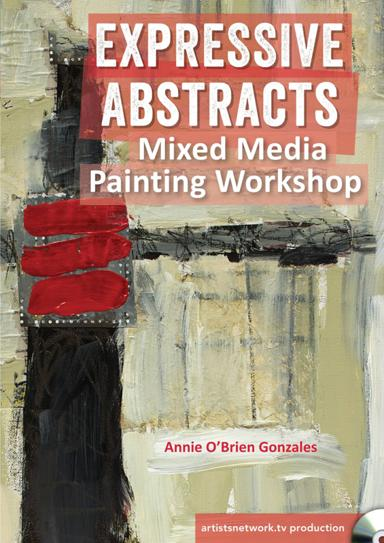Can you tell more about the style of artwork that appears on the poster? The artwork on the poster features a bold approach to abstract art, characterized by stark contrasts, bold color patches, and an intriguing blend of textures. Such elements reflect the typical style explored in the workshop, focusing on expressionism through abstract forms. 